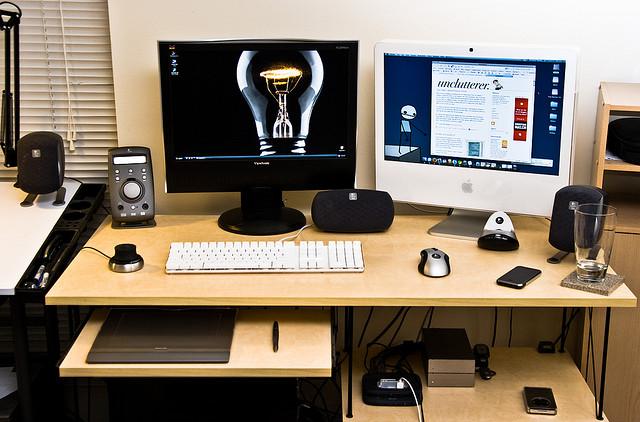What is the glass sitting on?
Give a very brief answer. Coaster. How many monitors does the desk have?
Be succinct. 2. Is the desk well organized?
Be succinct. Yes. 